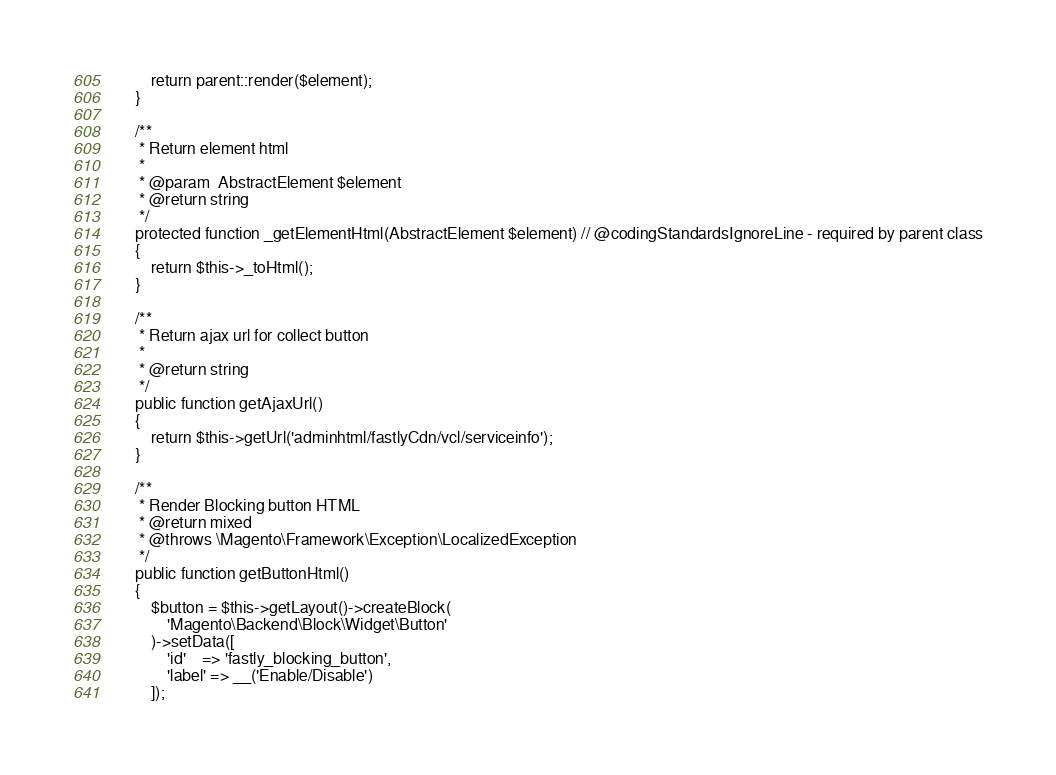<code> <loc_0><loc_0><loc_500><loc_500><_PHP_>        return parent::render($element);
    }

    /**
     * Return element html
     *
     * @param  AbstractElement $element
     * @return string
     */
    protected function _getElementHtml(AbstractElement $element) // @codingStandardsIgnoreLine - required by parent class
    {
        return $this->_toHtml();
    }

    /**
     * Return ajax url for collect button
     *
     * @return string
     */
    public function getAjaxUrl()
    {
        return $this->getUrl('adminhtml/fastlyCdn/vcl/serviceinfo');
    }

    /**
     * Render Blocking button HTML
     * @return mixed
     * @throws \Magento\Framework\Exception\LocalizedException
     */
    public function getButtonHtml()
    {
        $button = $this->getLayout()->createBlock(
            'Magento\Backend\Block\Widget\Button'
        )->setData([
            'id'    => 'fastly_blocking_button',
            'label' => __('Enable/Disable')
        ]);
</code> 